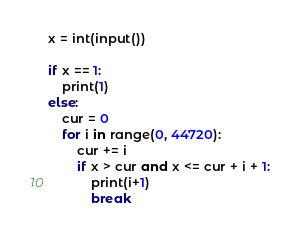<code> <loc_0><loc_0><loc_500><loc_500><_Python_>x = int(input())

if x == 1:
    print(1)
else:
    cur = 0
    for i in range(0, 44720):
        cur += i
        if x > cur and x <= cur + i + 1:
            print(i+1)
            break</code> 